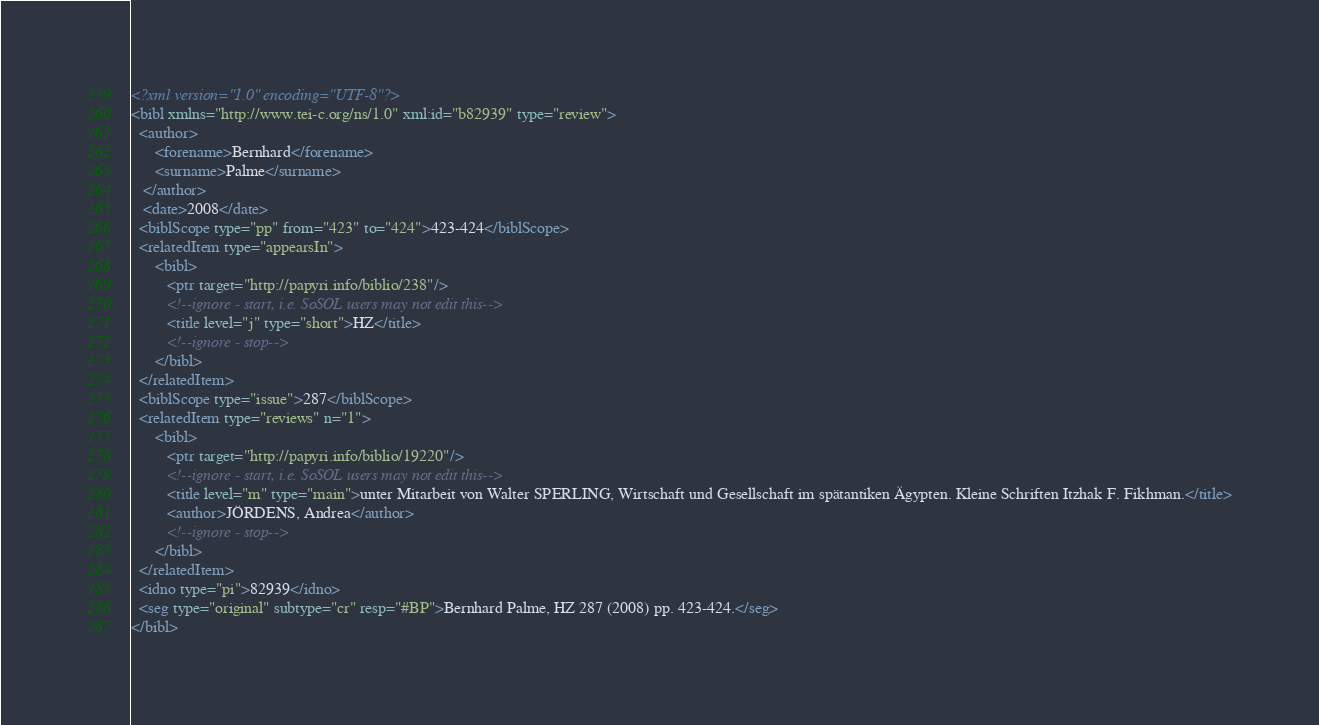Convert code to text. <code><loc_0><loc_0><loc_500><loc_500><_XML_><?xml version="1.0" encoding="UTF-8"?>
<bibl xmlns="http://www.tei-c.org/ns/1.0" xml:id="b82939" type="review">
  <author>
      <forename>Bernhard</forename>
      <surname>Palme</surname>
   </author>
   <date>2008</date>
  <biblScope type="pp" from="423" to="424">423-424</biblScope>
  <relatedItem type="appearsIn">
      <bibl>
         <ptr target="http://papyri.info/biblio/238"/>
         <!--ignore - start, i.e. SoSOL users may not edit this-->
         <title level="j" type="short">HZ</title>
         <!--ignore - stop-->
      </bibl>
  </relatedItem>
  <biblScope type="issue">287</biblScope>
  <relatedItem type="reviews" n="1">
      <bibl>
         <ptr target="http://papyri.info/biblio/19220"/>
         <!--ignore - start, i.e. SoSOL users may not edit this-->
         <title level="m" type="main">unter Mitarbeit von Walter SPERLING, Wirtschaft und Gesellschaft im spätantiken Ägypten. Kleine Schriften Itzhak F. Fikhman.</title>
         <author>JÖRDENS, Andrea</author>
         <!--ignore - stop-->
      </bibl>
  </relatedItem>
  <idno type="pi">82939</idno>
  <seg type="original" subtype="cr" resp="#BP">Bernhard Palme, HZ 287 (2008) pp. 423-424.</seg>
</bibl>
</code> 